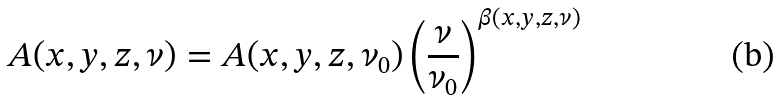Convert formula to latex. <formula><loc_0><loc_0><loc_500><loc_500>A ( x , y , z , \nu ) = A ( x , y , z , \nu _ { 0 } ) \left ( \frac { \nu } { \nu _ { 0 } } \right ) ^ { \beta ( x , y , z , \nu ) }</formula> 